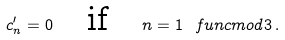Convert formula to latex. <formula><loc_0><loc_0><loc_500><loc_500>c _ { n } ^ { \prime } = 0 \quad \text {if\quad } n = 1 \ f u n c { m o d } 3 \, .</formula> 